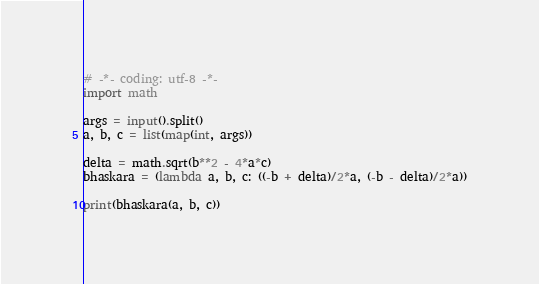<code> <loc_0><loc_0><loc_500><loc_500><_Python_># -*- coding: utf-8 -*-
import math

args = input().split()
a, b, c = list(map(int, args))

delta = math.sqrt(b**2 - 4*a*c)
bhaskara = (lambda a, b, c: ((-b + delta)/2*a, (-b - delta)/2*a))

print(bhaskara(a, b, c))

</code> 